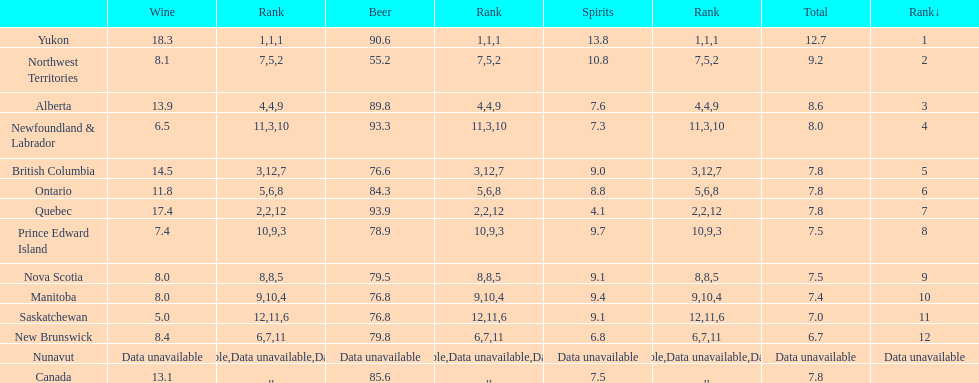Which province is the top consumer of wine? Yukon. 